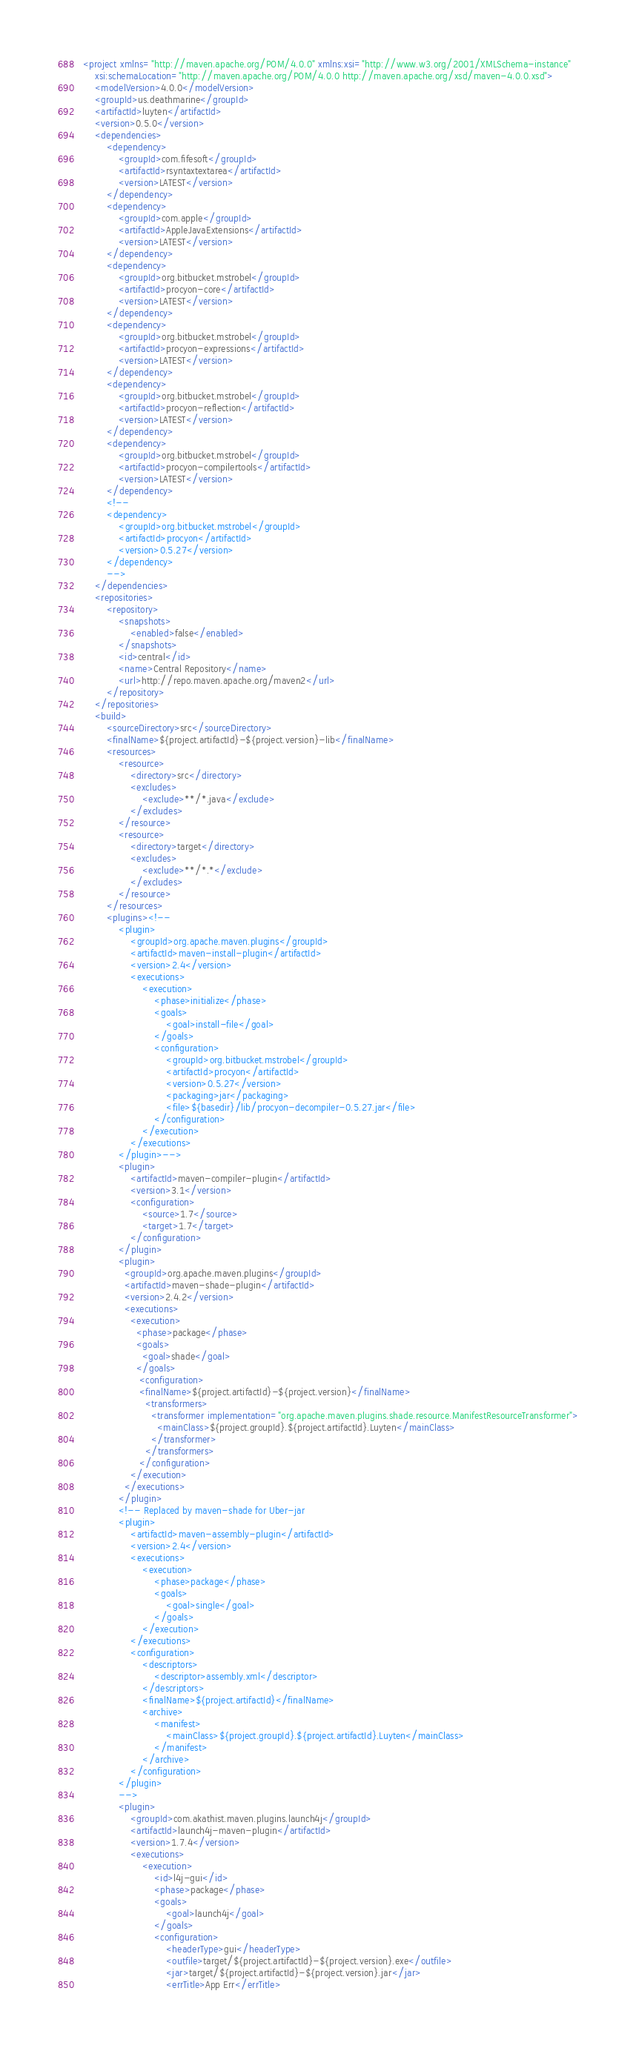Convert code to text. <code><loc_0><loc_0><loc_500><loc_500><_XML_><project xmlns="http://maven.apache.org/POM/4.0.0" xmlns:xsi="http://www.w3.org/2001/XMLSchema-instance"
	xsi:schemaLocation="http://maven.apache.org/POM/4.0.0 http://maven.apache.org/xsd/maven-4.0.0.xsd">
	<modelVersion>4.0.0</modelVersion>
	<groupId>us.deathmarine</groupId>
	<artifactId>luyten</artifactId>
	<version>0.5.0</version>
	<dependencies>
		<dependency>
			<groupId>com.fifesoft</groupId>
			<artifactId>rsyntaxtextarea</artifactId>
			<version>LATEST</version>
		</dependency>
		<dependency>
			<groupId>com.apple</groupId>
			<artifactId>AppleJavaExtensions</artifactId>
			<version>LATEST</version>
		</dependency>
		<dependency> 
			<groupId>org.bitbucket.mstrobel</groupId> 
			<artifactId>procyon-core</artifactId> 
			<version>LATEST</version> 
		</dependency> 
		<dependency> 
			<groupId>org.bitbucket.mstrobel</groupId> 
			<artifactId>procyon-expressions</artifactId> 
			<version>LATEST</version> 
		</dependency> 
		<dependency> 
			<groupId>org.bitbucket.mstrobel</groupId> 
			<artifactId>procyon-reflection</artifactId> 
			<version>LATEST</version> 
		</dependency> 
		<dependency> 
			<groupId>org.bitbucket.mstrobel</groupId> 
			<artifactId>procyon-compilertools</artifactId> 
			<version>LATEST</version> 
		</dependency> 
		<!--
		<dependency>
			<groupId>org.bitbucket.mstrobel</groupId>
			<artifactId>procyon</artifactId>
			<version>0.5.27</version>
		</dependency>
		-->
	</dependencies>
	<repositories>
		<repository>
			<snapshots>
				<enabled>false</enabled>
			</snapshots>
			<id>central</id>
			<name>Central Repository</name>
			<url>http://repo.maven.apache.org/maven2</url>
		</repository>
	</repositories>
	<build>
		<sourceDirectory>src</sourceDirectory>
		<finalName>${project.artifactId}-${project.version}-lib</finalName>
		<resources>
			<resource>
				<directory>src</directory>
				<excludes>
					<exclude>**/*.java</exclude>
				</excludes>
			</resource>
			<resource>
				<directory>target</directory>
				<excludes>
					<exclude>**/*.*</exclude>
				</excludes>
			</resource>
		</resources>
		<plugins><!--
			<plugin>
				<groupId>org.apache.maven.plugins</groupId>
				<artifactId>maven-install-plugin</artifactId>
				<version>2.4</version>
				<executions>
					<execution>
						<phase>initialize</phase>
						<goals>
							<goal>install-file</goal>
						</goals>
						<configuration>
							<groupId>org.bitbucket.mstrobel</groupId>
							<artifactId>procyon</artifactId>
							<version>0.5.27</version>
							<packaging>jar</packaging>
							<file>${basedir}/lib/procyon-decompiler-0.5.27.jar</file>
						</configuration>
					</execution>
				</executions>
			</plugin>-->
			<plugin>
				<artifactId>maven-compiler-plugin</artifactId>
				<version>3.1</version>
				<configuration>
					<source>1.7</source>
					<target>1.7</target>
				</configuration>
			</plugin>
			<plugin>
		      <groupId>org.apache.maven.plugins</groupId>
		      <artifactId>maven-shade-plugin</artifactId>
		      <version>2.4.2</version>
		      <executions>
		        <execution>
		          <phase>package</phase>
		          <goals>
		            <goal>shade</goal>
		          </goals>
		           <configuration>
		           <finalName>${project.artifactId}-${project.version}</finalName>
		             <transformers>
		               <transformer implementation="org.apache.maven.plugins.shade.resource.ManifestResourceTransformer">
		                 <mainClass>${project.groupId}.${project.artifactId}.Luyten</mainClass>
		               </transformer>
		             </transformers>
		           </configuration>
		        </execution>
		      </executions>
		    </plugin>
		    <!-- Replaced by maven-shade for Uber-jar
		    <plugin>
				<artifactId>maven-assembly-plugin</artifactId>
				<version>2.4</version>
				<executions>
					<execution>
						<phase>package</phase>
						<goals>
							<goal>single</goal>
						</goals>
					</execution>
				</executions>
				<configuration>
					<descriptors>
						<descriptor>assembly.xml</descriptor>
					</descriptors>
					<finalName>${project.artifactId}</finalName>
					<archive>
						<manifest>
							<mainClass>${project.groupId}.${project.artifactId}.Luyten</mainClass>
						</manifest>
					</archive>
				</configuration>
			</plugin> 
			-->
			<plugin>
         		<groupId>com.akathist.maven.plugins.launch4j</groupId>
        	    <artifactId>launch4j-maven-plugin</artifactId>
				<version>1.7.4</version>
				<executions>
					<execution>
						<id>l4j-gui</id>
						<phase>package</phase>
						<goals>
							<goal>launch4j</goal>
						</goals>
						<configuration>
							<headerType>gui</headerType>
							<outfile>target/${project.artifactId}-${project.version}.exe</outfile>
							<jar>target/${project.artifactId}-${project.version}.jar</jar>
							<errTitle>App Err</errTitle></code> 